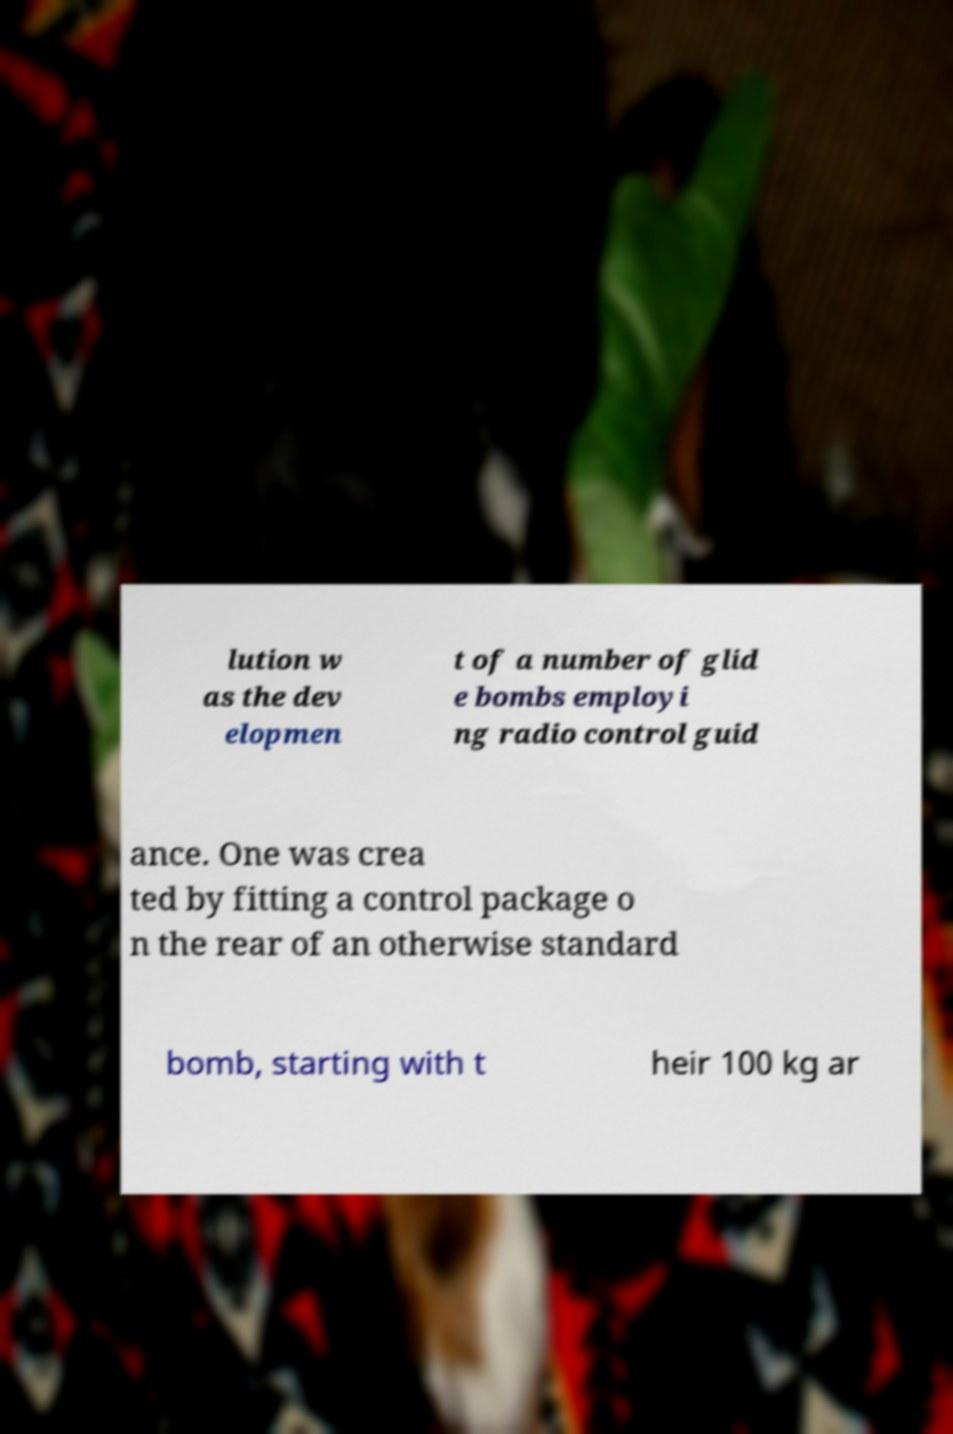Please identify and transcribe the text found in this image. lution w as the dev elopmen t of a number of glid e bombs employi ng radio control guid ance. One was crea ted by fitting a control package o n the rear of an otherwise standard bomb, starting with t heir 100 kg ar 